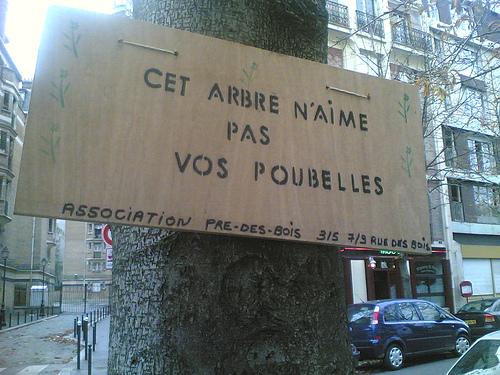Is this in the city?
Short answer required. Yes. What language is on the sign?
Be succinct. French. What is the date on the sign?
Quick response, please. 3/5. 